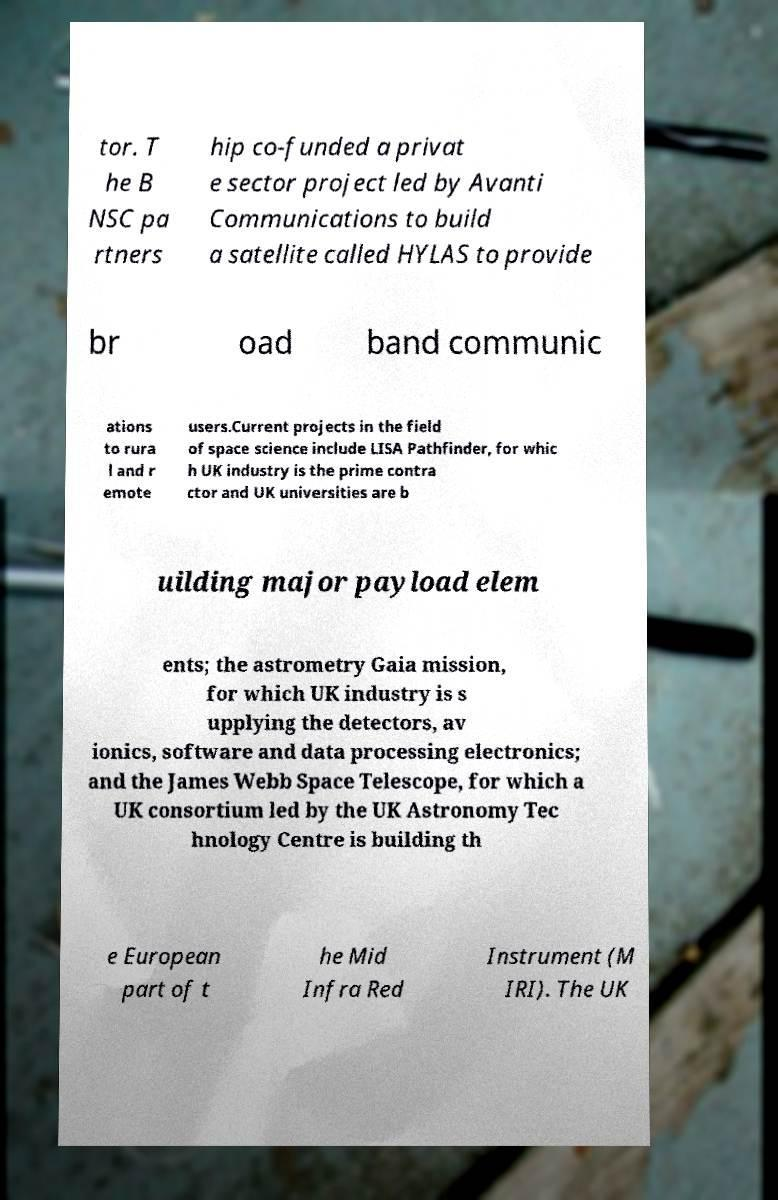For documentation purposes, I need the text within this image transcribed. Could you provide that? tor. T he B NSC pa rtners hip co-funded a privat e sector project led by Avanti Communications to build a satellite called HYLAS to provide br oad band communic ations to rura l and r emote users.Current projects in the field of space science include LISA Pathfinder, for whic h UK industry is the prime contra ctor and UK universities are b uilding major payload elem ents; the astrometry Gaia mission, for which UK industry is s upplying the detectors, av ionics, software and data processing electronics; and the James Webb Space Telescope, for which a UK consortium led by the UK Astronomy Tec hnology Centre is building th e European part of t he Mid Infra Red Instrument (M IRI). The UK 